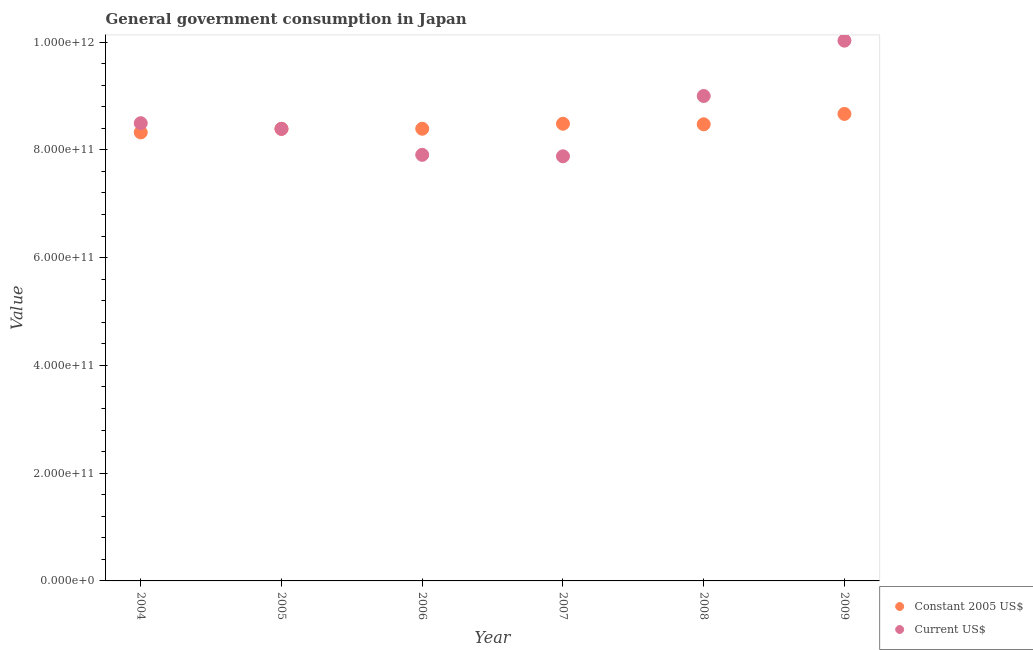What is the value consumed in constant 2005 us$ in 2006?
Offer a terse response. 8.39e+11. Across all years, what is the maximum value consumed in constant 2005 us$?
Ensure brevity in your answer.  8.67e+11. Across all years, what is the minimum value consumed in constant 2005 us$?
Offer a very short reply. 8.32e+11. In which year was the value consumed in current us$ maximum?
Offer a very short reply. 2009. In which year was the value consumed in constant 2005 us$ minimum?
Give a very brief answer. 2004. What is the total value consumed in constant 2005 us$ in the graph?
Give a very brief answer. 5.07e+12. What is the difference between the value consumed in constant 2005 us$ in 2006 and that in 2008?
Ensure brevity in your answer.  -8.26e+09. What is the difference between the value consumed in current us$ in 2007 and the value consumed in constant 2005 us$ in 2009?
Offer a very short reply. -7.87e+1. What is the average value consumed in constant 2005 us$ per year?
Keep it short and to the point. 8.46e+11. In the year 2004, what is the difference between the value consumed in constant 2005 us$ and value consumed in current us$?
Your answer should be compact. -1.71e+1. In how many years, is the value consumed in current us$ greater than 640000000000?
Your response must be concise. 6. What is the ratio of the value consumed in current us$ in 2004 to that in 2009?
Your answer should be very brief. 0.85. Is the value consumed in constant 2005 us$ in 2004 less than that in 2006?
Make the answer very short. Yes. Is the difference between the value consumed in constant 2005 us$ in 2004 and 2009 greater than the difference between the value consumed in current us$ in 2004 and 2009?
Give a very brief answer. Yes. What is the difference between the highest and the second highest value consumed in constant 2005 us$?
Offer a very short reply. 1.82e+1. What is the difference between the highest and the lowest value consumed in constant 2005 us$?
Give a very brief answer. 3.43e+1. Does the value consumed in constant 2005 us$ monotonically increase over the years?
Your answer should be very brief. No. How many dotlines are there?
Your answer should be very brief. 2. What is the difference between two consecutive major ticks on the Y-axis?
Offer a very short reply. 2.00e+11. Does the graph contain any zero values?
Your answer should be very brief. No. Where does the legend appear in the graph?
Give a very brief answer. Bottom right. How many legend labels are there?
Give a very brief answer. 2. What is the title of the graph?
Provide a short and direct response. General government consumption in Japan. What is the label or title of the Y-axis?
Provide a short and direct response. Value. What is the Value in Constant 2005 US$ in 2004?
Your answer should be very brief. 8.32e+11. What is the Value of Current US$ in 2004?
Provide a short and direct response. 8.49e+11. What is the Value in Constant 2005 US$ in 2005?
Keep it short and to the point. 8.39e+11. What is the Value of Current US$ in 2005?
Offer a very short reply. 8.39e+11. What is the Value of Constant 2005 US$ in 2006?
Give a very brief answer. 8.39e+11. What is the Value of Current US$ in 2006?
Your response must be concise. 7.91e+11. What is the Value in Constant 2005 US$ in 2007?
Give a very brief answer. 8.49e+11. What is the Value in Current US$ in 2007?
Your answer should be very brief. 7.88e+11. What is the Value in Constant 2005 US$ in 2008?
Give a very brief answer. 8.47e+11. What is the Value in Current US$ in 2008?
Give a very brief answer. 9.00e+11. What is the Value in Constant 2005 US$ in 2009?
Offer a terse response. 8.67e+11. What is the Value in Current US$ in 2009?
Keep it short and to the point. 1.00e+12. Across all years, what is the maximum Value in Constant 2005 US$?
Your answer should be compact. 8.67e+11. Across all years, what is the maximum Value of Current US$?
Your answer should be very brief. 1.00e+12. Across all years, what is the minimum Value in Constant 2005 US$?
Provide a succinct answer. 8.32e+11. Across all years, what is the minimum Value in Current US$?
Give a very brief answer. 7.88e+11. What is the total Value of Constant 2005 US$ in the graph?
Provide a short and direct response. 5.07e+12. What is the total Value in Current US$ in the graph?
Keep it short and to the point. 5.17e+12. What is the difference between the Value of Constant 2005 US$ in 2004 and that in 2005?
Your response must be concise. -6.57e+09. What is the difference between the Value in Current US$ in 2004 and that in 2005?
Your answer should be compact. 1.05e+1. What is the difference between the Value of Constant 2005 US$ in 2004 and that in 2006?
Your answer should be very brief. -6.80e+09. What is the difference between the Value of Current US$ in 2004 and that in 2006?
Ensure brevity in your answer.  5.87e+1. What is the difference between the Value in Constant 2005 US$ in 2004 and that in 2007?
Keep it short and to the point. -1.61e+1. What is the difference between the Value in Current US$ in 2004 and that in 2007?
Ensure brevity in your answer.  6.15e+1. What is the difference between the Value in Constant 2005 US$ in 2004 and that in 2008?
Offer a terse response. -1.51e+1. What is the difference between the Value of Current US$ in 2004 and that in 2008?
Make the answer very short. -5.05e+1. What is the difference between the Value in Constant 2005 US$ in 2004 and that in 2009?
Offer a very short reply. -3.43e+1. What is the difference between the Value in Current US$ in 2004 and that in 2009?
Offer a terse response. -1.53e+11. What is the difference between the Value of Constant 2005 US$ in 2005 and that in 2006?
Provide a short and direct response. -2.30e+08. What is the difference between the Value of Current US$ in 2005 and that in 2006?
Make the answer very short. 4.82e+1. What is the difference between the Value in Constant 2005 US$ in 2005 and that in 2007?
Your answer should be very brief. -9.56e+09. What is the difference between the Value in Current US$ in 2005 and that in 2007?
Keep it short and to the point. 5.09e+1. What is the difference between the Value of Constant 2005 US$ in 2005 and that in 2008?
Give a very brief answer. -8.49e+09. What is the difference between the Value in Current US$ in 2005 and that in 2008?
Ensure brevity in your answer.  -6.10e+1. What is the difference between the Value of Constant 2005 US$ in 2005 and that in 2009?
Offer a terse response. -2.77e+1. What is the difference between the Value of Current US$ in 2005 and that in 2009?
Offer a very short reply. -1.64e+11. What is the difference between the Value in Constant 2005 US$ in 2006 and that in 2007?
Offer a terse response. -9.33e+09. What is the difference between the Value of Current US$ in 2006 and that in 2007?
Give a very brief answer. 2.75e+09. What is the difference between the Value in Constant 2005 US$ in 2006 and that in 2008?
Offer a terse response. -8.26e+09. What is the difference between the Value of Current US$ in 2006 and that in 2008?
Make the answer very short. -1.09e+11. What is the difference between the Value of Constant 2005 US$ in 2006 and that in 2009?
Offer a terse response. -2.75e+1. What is the difference between the Value of Current US$ in 2006 and that in 2009?
Your answer should be compact. -2.12e+11. What is the difference between the Value in Constant 2005 US$ in 2007 and that in 2008?
Give a very brief answer. 1.07e+09. What is the difference between the Value of Current US$ in 2007 and that in 2008?
Ensure brevity in your answer.  -1.12e+11. What is the difference between the Value in Constant 2005 US$ in 2007 and that in 2009?
Offer a very short reply. -1.82e+1. What is the difference between the Value in Current US$ in 2007 and that in 2009?
Provide a short and direct response. -2.15e+11. What is the difference between the Value in Constant 2005 US$ in 2008 and that in 2009?
Your answer should be compact. -1.92e+1. What is the difference between the Value in Current US$ in 2008 and that in 2009?
Make the answer very short. -1.03e+11. What is the difference between the Value in Constant 2005 US$ in 2004 and the Value in Current US$ in 2005?
Offer a very short reply. -6.57e+09. What is the difference between the Value in Constant 2005 US$ in 2004 and the Value in Current US$ in 2006?
Offer a very short reply. 4.16e+1. What is the difference between the Value in Constant 2005 US$ in 2004 and the Value in Current US$ in 2007?
Offer a terse response. 4.44e+1. What is the difference between the Value in Constant 2005 US$ in 2004 and the Value in Current US$ in 2008?
Offer a terse response. -6.76e+1. What is the difference between the Value in Constant 2005 US$ in 2004 and the Value in Current US$ in 2009?
Offer a terse response. -1.70e+11. What is the difference between the Value in Constant 2005 US$ in 2005 and the Value in Current US$ in 2006?
Your answer should be very brief. 4.82e+1. What is the difference between the Value in Constant 2005 US$ in 2005 and the Value in Current US$ in 2007?
Give a very brief answer. 5.09e+1. What is the difference between the Value of Constant 2005 US$ in 2005 and the Value of Current US$ in 2008?
Keep it short and to the point. -6.10e+1. What is the difference between the Value of Constant 2005 US$ in 2005 and the Value of Current US$ in 2009?
Keep it short and to the point. -1.64e+11. What is the difference between the Value in Constant 2005 US$ in 2006 and the Value in Current US$ in 2007?
Give a very brief answer. 5.12e+1. What is the difference between the Value of Constant 2005 US$ in 2006 and the Value of Current US$ in 2008?
Ensure brevity in your answer.  -6.08e+1. What is the difference between the Value of Constant 2005 US$ in 2006 and the Value of Current US$ in 2009?
Offer a terse response. -1.63e+11. What is the difference between the Value in Constant 2005 US$ in 2007 and the Value in Current US$ in 2008?
Provide a succinct answer. -5.14e+1. What is the difference between the Value of Constant 2005 US$ in 2007 and the Value of Current US$ in 2009?
Provide a short and direct response. -1.54e+11. What is the difference between the Value of Constant 2005 US$ in 2008 and the Value of Current US$ in 2009?
Offer a terse response. -1.55e+11. What is the average Value in Constant 2005 US$ per year?
Ensure brevity in your answer.  8.46e+11. What is the average Value in Current US$ per year?
Your answer should be very brief. 8.62e+11. In the year 2004, what is the difference between the Value of Constant 2005 US$ and Value of Current US$?
Your answer should be compact. -1.71e+1. In the year 2006, what is the difference between the Value in Constant 2005 US$ and Value in Current US$?
Give a very brief answer. 4.84e+1. In the year 2007, what is the difference between the Value of Constant 2005 US$ and Value of Current US$?
Your answer should be compact. 6.05e+1. In the year 2008, what is the difference between the Value in Constant 2005 US$ and Value in Current US$?
Give a very brief answer. -5.25e+1. In the year 2009, what is the difference between the Value in Constant 2005 US$ and Value in Current US$?
Make the answer very short. -1.36e+11. What is the ratio of the Value of Constant 2005 US$ in 2004 to that in 2005?
Provide a short and direct response. 0.99. What is the ratio of the Value in Current US$ in 2004 to that in 2005?
Keep it short and to the point. 1.01. What is the ratio of the Value of Constant 2005 US$ in 2004 to that in 2006?
Make the answer very short. 0.99. What is the ratio of the Value of Current US$ in 2004 to that in 2006?
Your response must be concise. 1.07. What is the ratio of the Value in Current US$ in 2004 to that in 2007?
Your answer should be compact. 1.08. What is the ratio of the Value in Constant 2005 US$ in 2004 to that in 2008?
Keep it short and to the point. 0.98. What is the ratio of the Value of Current US$ in 2004 to that in 2008?
Give a very brief answer. 0.94. What is the ratio of the Value in Constant 2005 US$ in 2004 to that in 2009?
Your answer should be very brief. 0.96. What is the ratio of the Value of Current US$ in 2004 to that in 2009?
Give a very brief answer. 0.85. What is the ratio of the Value in Current US$ in 2005 to that in 2006?
Offer a very short reply. 1.06. What is the ratio of the Value of Constant 2005 US$ in 2005 to that in 2007?
Provide a succinct answer. 0.99. What is the ratio of the Value in Current US$ in 2005 to that in 2007?
Your answer should be compact. 1.06. What is the ratio of the Value of Constant 2005 US$ in 2005 to that in 2008?
Offer a very short reply. 0.99. What is the ratio of the Value of Current US$ in 2005 to that in 2008?
Keep it short and to the point. 0.93. What is the ratio of the Value of Current US$ in 2005 to that in 2009?
Your answer should be very brief. 0.84. What is the ratio of the Value in Constant 2005 US$ in 2006 to that in 2007?
Ensure brevity in your answer.  0.99. What is the ratio of the Value in Current US$ in 2006 to that in 2007?
Offer a very short reply. 1. What is the ratio of the Value in Constant 2005 US$ in 2006 to that in 2008?
Keep it short and to the point. 0.99. What is the ratio of the Value in Current US$ in 2006 to that in 2008?
Provide a succinct answer. 0.88. What is the ratio of the Value of Constant 2005 US$ in 2006 to that in 2009?
Your response must be concise. 0.97. What is the ratio of the Value of Current US$ in 2006 to that in 2009?
Offer a terse response. 0.79. What is the ratio of the Value of Current US$ in 2007 to that in 2008?
Provide a short and direct response. 0.88. What is the ratio of the Value of Constant 2005 US$ in 2007 to that in 2009?
Offer a very short reply. 0.98. What is the ratio of the Value in Current US$ in 2007 to that in 2009?
Offer a very short reply. 0.79. What is the ratio of the Value in Constant 2005 US$ in 2008 to that in 2009?
Give a very brief answer. 0.98. What is the ratio of the Value of Current US$ in 2008 to that in 2009?
Provide a succinct answer. 0.9. What is the difference between the highest and the second highest Value in Constant 2005 US$?
Offer a very short reply. 1.82e+1. What is the difference between the highest and the second highest Value in Current US$?
Offer a very short reply. 1.03e+11. What is the difference between the highest and the lowest Value of Constant 2005 US$?
Keep it short and to the point. 3.43e+1. What is the difference between the highest and the lowest Value in Current US$?
Offer a terse response. 2.15e+11. 